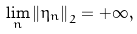Convert formula to latex. <formula><loc_0><loc_0><loc_500><loc_500>\lim _ { n } \left \| \eta _ { n } \right \| _ { 2 } = + \infty ,</formula> 